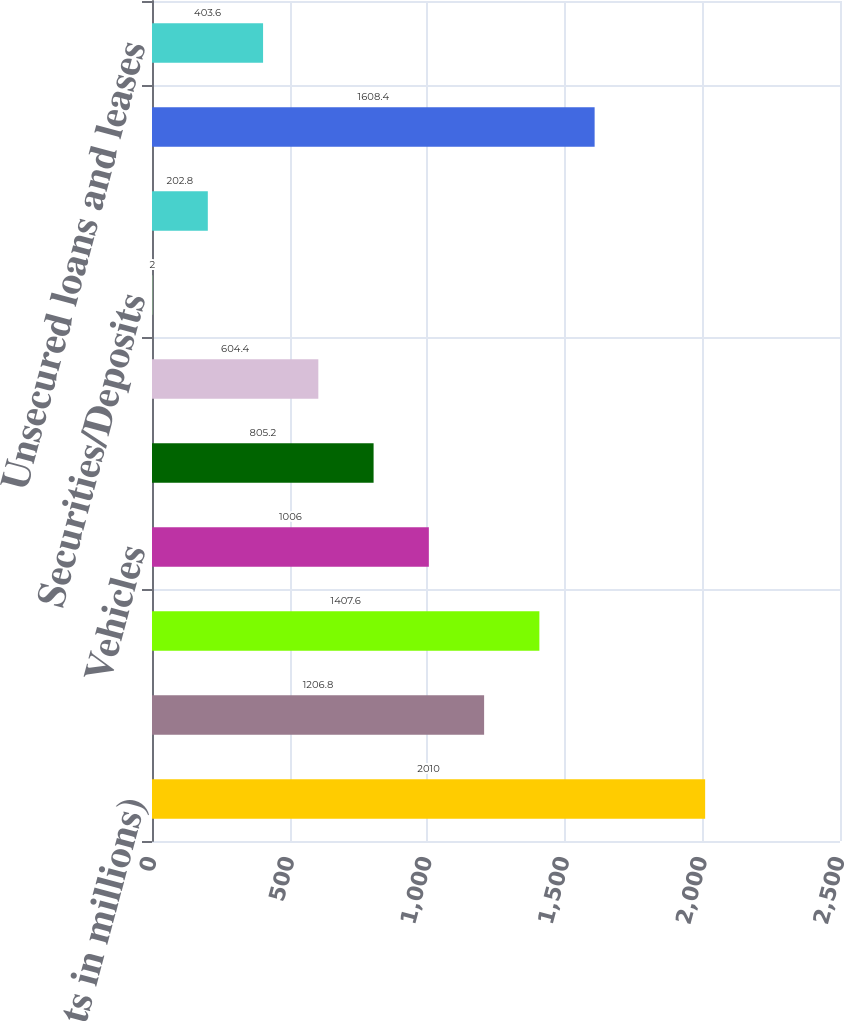Convert chart to OTSL. <chart><loc_0><loc_0><loc_500><loc_500><bar_chart><fcel>(dollar amounts in millions)<fcel>Real estate - commercial<fcel>Real estate - consumer<fcel>Vehicles<fcel>Receivables/Inventory<fcel>Machinery/Equipment<fcel>Securities/Deposits<fcel>Other<fcel>Total secured loans and leases<fcel>Unsecured loans and leases<nl><fcel>2010<fcel>1206.8<fcel>1407.6<fcel>1006<fcel>805.2<fcel>604.4<fcel>2<fcel>202.8<fcel>1608.4<fcel>403.6<nl></chart> 